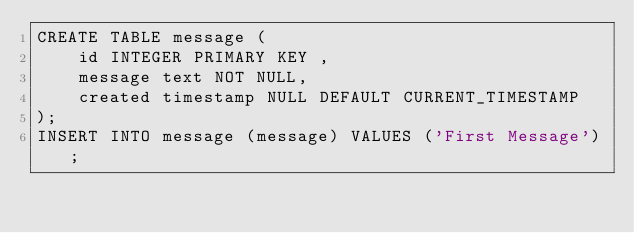<code> <loc_0><loc_0><loc_500><loc_500><_SQL_>CREATE TABLE message (
    id INTEGER PRIMARY KEY , 
    message text NOT NULL,
    created timestamp NULL DEFAULT CURRENT_TIMESTAMP    
);
INSERT INTO message (message) VALUES ('First Message');</code> 